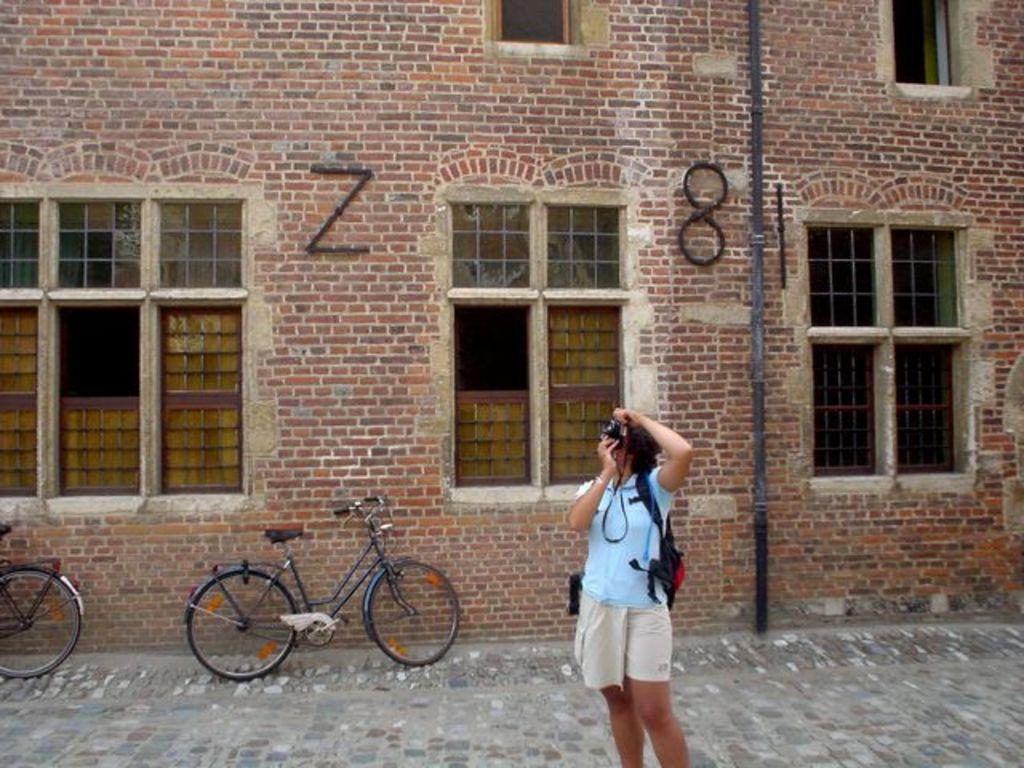Can you describe this image briefly? In this image there is a lady standing on the road and shooting with the camera and she is wearing a bag on her shoulder, behind her there is a building with red bricks and there are two bicycles. 